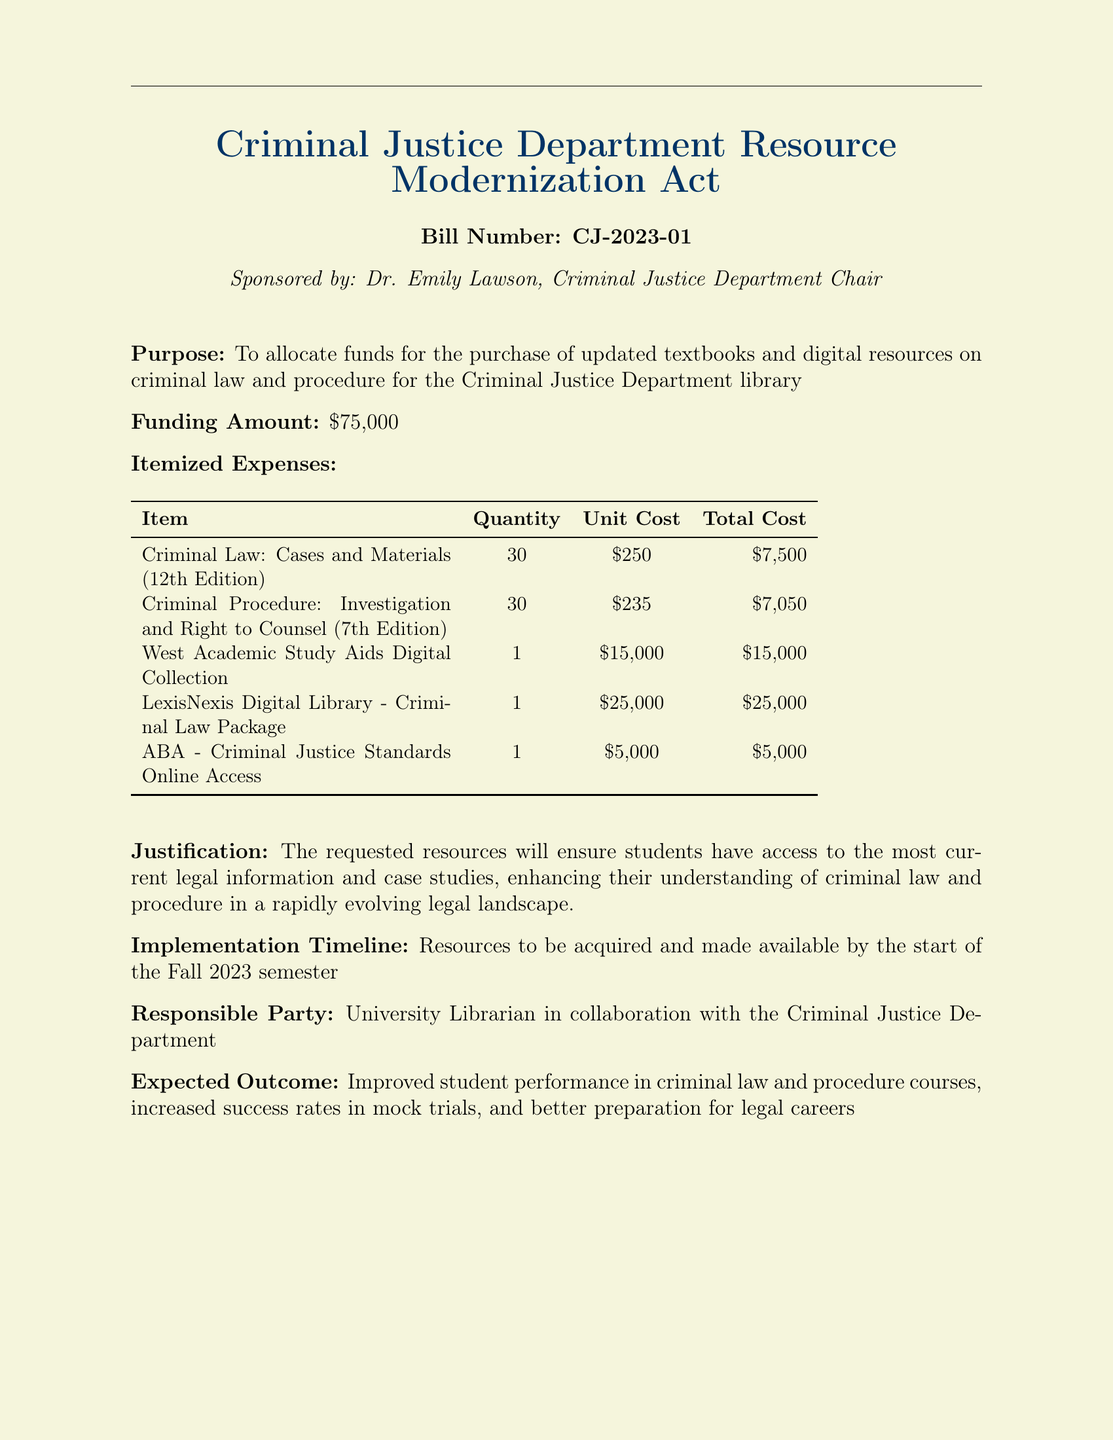What is the bill number? The bill number is explicitly stated in the document under the title section.
Answer: CJ-2023-01 Who is the sponsor of the bill? The sponsor of the bill is mentioned alongside the bill title, indicating their role.
Answer: Dr. Emily Lawson What is the funding amount requested? The funding amount is specified in the financial section of the bill.
Answer: $75,000 How many copies of "Criminal Law: Cases and Materials" are requested? The quantity for this textbook is detailed in the itemized expenses table.
Answer: 30 What is the total cost for the "LexisNexis Digital Library - Criminal Law Package"? The total cost for this item is provided in the expense table and represents a significant investment.
Answer: $25,000 What is the implementation timeline for acquiring the resources? The implementation timeline is outlined in the document to provide clarity on when resources will be available.
Answer: Fall 2023 semester What is the expected outcome of the bill? The expected outcomes are summarized to highlight the benefits of passing the bill.
Answer: Improved student performance Which entity is responsible for managing the acquisition of resources? The responsible party is clearly stated in the document regarding who will oversee the implementation.
Answer: University Librarian What digital collection is included in the itemized expenses? The specific collection that is planned to be acquired is named in the expense table.
Answer: West Academic Study Aids Digital Collection 